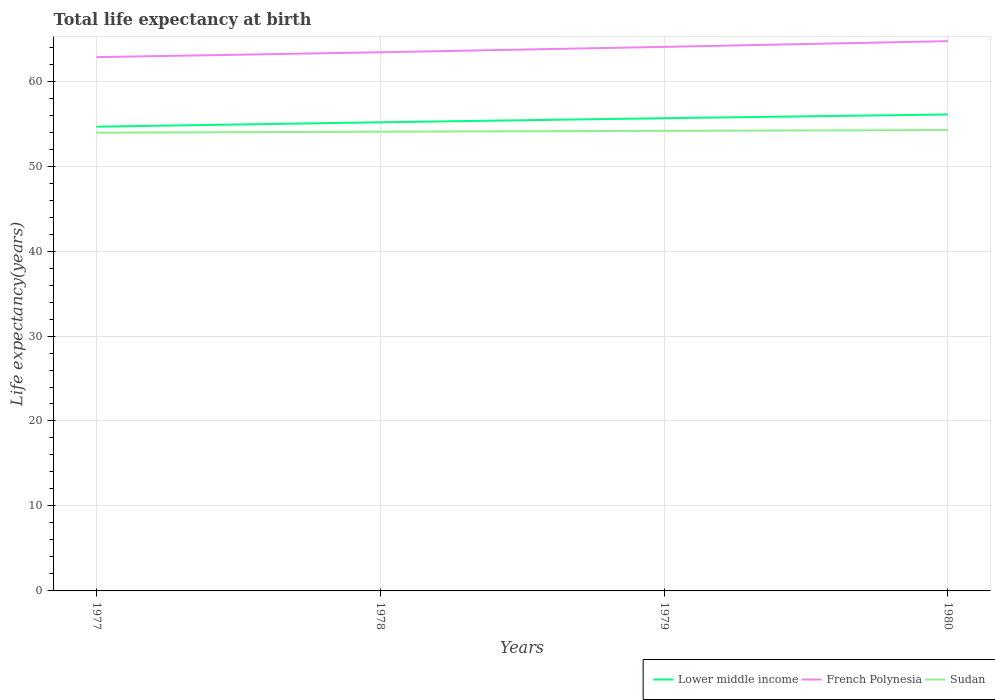Is the number of lines equal to the number of legend labels?
Your answer should be compact. Yes. Across all years, what is the maximum life expectancy at birth in in French Polynesia?
Your answer should be very brief. 62.82. In which year was the life expectancy at birth in in Lower middle income maximum?
Offer a very short reply. 1977. What is the total life expectancy at birth in in Sudan in the graph?
Provide a short and direct response. -0.12. What is the difference between the highest and the second highest life expectancy at birth in in Lower middle income?
Ensure brevity in your answer.  1.44. Is the life expectancy at birth in in Lower middle income strictly greater than the life expectancy at birth in in Sudan over the years?
Provide a succinct answer. No. How many lines are there?
Give a very brief answer. 3. Are the values on the major ticks of Y-axis written in scientific E-notation?
Your answer should be compact. No. How many legend labels are there?
Your answer should be compact. 3. What is the title of the graph?
Offer a terse response. Total life expectancy at birth. Does "Brunei Darussalam" appear as one of the legend labels in the graph?
Provide a succinct answer. No. What is the label or title of the Y-axis?
Give a very brief answer. Life expectancy(years). What is the Life expectancy(years) of Lower middle income in 1977?
Your answer should be compact. 54.64. What is the Life expectancy(years) in French Polynesia in 1977?
Ensure brevity in your answer.  62.82. What is the Life expectancy(years) of Sudan in 1977?
Provide a short and direct response. 53.93. What is the Life expectancy(years) of Lower middle income in 1978?
Provide a short and direct response. 55.16. What is the Life expectancy(years) in French Polynesia in 1978?
Offer a terse response. 63.4. What is the Life expectancy(years) in Sudan in 1978?
Keep it short and to the point. 54.05. What is the Life expectancy(years) in Lower middle income in 1979?
Offer a terse response. 55.64. What is the Life expectancy(years) of French Polynesia in 1979?
Provide a short and direct response. 64.03. What is the Life expectancy(years) of Sudan in 1979?
Ensure brevity in your answer.  54.15. What is the Life expectancy(years) of Lower middle income in 1980?
Your answer should be compact. 56.08. What is the Life expectancy(years) in French Polynesia in 1980?
Your answer should be very brief. 64.71. What is the Life expectancy(years) in Sudan in 1980?
Provide a succinct answer. 54.24. Across all years, what is the maximum Life expectancy(years) in Lower middle income?
Your response must be concise. 56.08. Across all years, what is the maximum Life expectancy(years) of French Polynesia?
Your response must be concise. 64.71. Across all years, what is the maximum Life expectancy(years) of Sudan?
Make the answer very short. 54.24. Across all years, what is the minimum Life expectancy(years) in Lower middle income?
Provide a short and direct response. 54.64. Across all years, what is the minimum Life expectancy(years) in French Polynesia?
Offer a very short reply. 62.82. Across all years, what is the minimum Life expectancy(years) of Sudan?
Your response must be concise. 53.93. What is the total Life expectancy(years) of Lower middle income in the graph?
Ensure brevity in your answer.  221.51. What is the total Life expectancy(years) in French Polynesia in the graph?
Provide a succinct answer. 254.96. What is the total Life expectancy(years) in Sudan in the graph?
Keep it short and to the point. 216.37. What is the difference between the Life expectancy(years) in Lower middle income in 1977 and that in 1978?
Ensure brevity in your answer.  -0.52. What is the difference between the Life expectancy(years) in French Polynesia in 1977 and that in 1978?
Keep it short and to the point. -0.57. What is the difference between the Life expectancy(years) in Sudan in 1977 and that in 1978?
Ensure brevity in your answer.  -0.12. What is the difference between the Life expectancy(years) of Lower middle income in 1977 and that in 1979?
Provide a short and direct response. -1. What is the difference between the Life expectancy(years) of French Polynesia in 1977 and that in 1979?
Keep it short and to the point. -1.21. What is the difference between the Life expectancy(years) in Sudan in 1977 and that in 1979?
Offer a terse response. -0.22. What is the difference between the Life expectancy(years) of Lower middle income in 1977 and that in 1980?
Give a very brief answer. -1.44. What is the difference between the Life expectancy(years) in French Polynesia in 1977 and that in 1980?
Keep it short and to the point. -1.88. What is the difference between the Life expectancy(years) of Sudan in 1977 and that in 1980?
Offer a very short reply. -0.31. What is the difference between the Life expectancy(years) of Lower middle income in 1978 and that in 1979?
Your response must be concise. -0.48. What is the difference between the Life expectancy(years) of French Polynesia in 1978 and that in 1979?
Your response must be concise. -0.64. What is the difference between the Life expectancy(years) in Lower middle income in 1978 and that in 1980?
Keep it short and to the point. -0.92. What is the difference between the Life expectancy(years) in French Polynesia in 1978 and that in 1980?
Offer a very short reply. -1.31. What is the difference between the Life expectancy(years) of Sudan in 1978 and that in 1980?
Ensure brevity in your answer.  -0.19. What is the difference between the Life expectancy(years) of Lower middle income in 1979 and that in 1980?
Give a very brief answer. -0.44. What is the difference between the Life expectancy(years) of French Polynesia in 1979 and that in 1980?
Your answer should be compact. -0.67. What is the difference between the Life expectancy(years) of Sudan in 1979 and that in 1980?
Make the answer very short. -0.09. What is the difference between the Life expectancy(years) in Lower middle income in 1977 and the Life expectancy(years) in French Polynesia in 1978?
Your answer should be very brief. -8.76. What is the difference between the Life expectancy(years) in Lower middle income in 1977 and the Life expectancy(years) in Sudan in 1978?
Give a very brief answer. 0.59. What is the difference between the Life expectancy(years) in French Polynesia in 1977 and the Life expectancy(years) in Sudan in 1978?
Your answer should be very brief. 8.78. What is the difference between the Life expectancy(years) of Lower middle income in 1977 and the Life expectancy(years) of French Polynesia in 1979?
Your answer should be compact. -9.39. What is the difference between the Life expectancy(years) of Lower middle income in 1977 and the Life expectancy(years) of Sudan in 1979?
Offer a very short reply. 0.49. What is the difference between the Life expectancy(years) of French Polynesia in 1977 and the Life expectancy(years) of Sudan in 1979?
Your answer should be compact. 8.68. What is the difference between the Life expectancy(years) in Lower middle income in 1977 and the Life expectancy(years) in French Polynesia in 1980?
Make the answer very short. -10.07. What is the difference between the Life expectancy(years) in Lower middle income in 1977 and the Life expectancy(years) in Sudan in 1980?
Provide a succinct answer. 0.4. What is the difference between the Life expectancy(years) of French Polynesia in 1977 and the Life expectancy(years) of Sudan in 1980?
Your response must be concise. 8.58. What is the difference between the Life expectancy(years) in Lower middle income in 1978 and the Life expectancy(years) in French Polynesia in 1979?
Give a very brief answer. -8.88. What is the difference between the Life expectancy(years) in Lower middle income in 1978 and the Life expectancy(years) in Sudan in 1979?
Your response must be concise. 1.01. What is the difference between the Life expectancy(years) of French Polynesia in 1978 and the Life expectancy(years) of Sudan in 1979?
Your response must be concise. 9.25. What is the difference between the Life expectancy(years) in Lower middle income in 1978 and the Life expectancy(years) in French Polynesia in 1980?
Your answer should be very brief. -9.55. What is the difference between the Life expectancy(years) of Lower middle income in 1978 and the Life expectancy(years) of Sudan in 1980?
Keep it short and to the point. 0.92. What is the difference between the Life expectancy(years) in French Polynesia in 1978 and the Life expectancy(years) in Sudan in 1980?
Offer a very short reply. 9.15. What is the difference between the Life expectancy(years) in Lower middle income in 1979 and the Life expectancy(years) in French Polynesia in 1980?
Your response must be concise. -9.07. What is the difference between the Life expectancy(years) in Lower middle income in 1979 and the Life expectancy(years) in Sudan in 1980?
Your response must be concise. 1.4. What is the difference between the Life expectancy(years) of French Polynesia in 1979 and the Life expectancy(years) of Sudan in 1980?
Provide a short and direct response. 9.79. What is the average Life expectancy(years) in Lower middle income per year?
Give a very brief answer. 55.38. What is the average Life expectancy(years) of French Polynesia per year?
Offer a terse response. 63.74. What is the average Life expectancy(years) in Sudan per year?
Make the answer very short. 54.09. In the year 1977, what is the difference between the Life expectancy(years) of Lower middle income and Life expectancy(years) of French Polynesia?
Make the answer very short. -8.19. In the year 1977, what is the difference between the Life expectancy(years) of Lower middle income and Life expectancy(years) of Sudan?
Offer a very short reply. 0.71. In the year 1977, what is the difference between the Life expectancy(years) of French Polynesia and Life expectancy(years) of Sudan?
Offer a terse response. 8.89. In the year 1978, what is the difference between the Life expectancy(years) of Lower middle income and Life expectancy(years) of French Polynesia?
Make the answer very short. -8.24. In the year 1978, what is the difference between the Life expectancy(years) in Lower middle income and Life expectancy(years) in Sudan?
Provide a succinct answer. 1.11. In the year 1978, what is the difference between the Life expectancy(years) in French Polynesia and Life expectancy(years) in Sudan?
Ensure brevity in your answer.  9.35. In the year 1979, what is the difference between the Life expectancy(years) of Lower middle income and Life expectancy(years) of French Polynesia?
Keep it short and to the point. -8.39. In the year 1979, what is the difference between the Life expectancy(years) of Lower middle income and Life expectancy(years) of Sudan?
Make the answer very short. 1.49. In the year 1979, what is the difference between the Life expectancy(years) in French Polynesia and Life expectancy(years) in Sudan?
Your answer should be compact. 9.88. In the year 1980, what is the difference between the Life expectancy(years) of Lower middle income and Life expectancy(years) of French Polynesia?
Your response must be concise. -8.63. In the year 1980, what is the difference between the Life expectancy(years) in Lower middle income and Life expectancy(years) in Sudan?
Your answer should be very brief. 1.84. In the year 1980, what is the difference between the Life expectancy(years) of French Polynesia and Life expectancy(years) of Sudan?
Give a very brief answer. 10.46. What is the ratio of the Life expectancy(years) in Lower middle income in 1977 to that in 1978?
Your response must be concise. 0.99. What is the ratio of the Life expectancy(years) of French Polynesia in 1977 to that in 1978?
Provide a short and direct response. 0.99. What is the ratio of the Life expectancy(years) in Sudan in 1977 to that in 1978?
Ensure brevity in your answer.  1. What is the ratio of the Life expectancy(years) in Lower middle income in 1977 to that in 1979?
Make the answer very short. 0.98. What is the ratio of the Life expectancy(years) of French Polynesia in 1977 to that in 1979?
Provide a succinct answer. 0.98. What is the ratio of the Life expectancy(years) of Lower middle income in 1977 to that in 1980?
Your answer should be compact. 0.97. What is the ratio of the Life expectancy(years) in French Polynesia in 1977 to that in 1980?
Offer a terse response. 0.97. What is the ratio of the Life expectancy(years) of Sudan in 1977 to that in 1980?
Your answer should be very brief. 0.99. What is the ratio of the Life expectancy(years) of Sudan in 1978 to that in 1979?
Offer a terse response. 1. What is the ratio of the Life expectancy(years) in Lower middle income in 1978 to that in 1980?
Provide a succinct answer. 0.98. What is the ratio of the Life expectancy(years) of French Polynesia in 1978 to that in 1980?
Offer a terse response. 0.98. What is the ratio of the Life expectancy(years) in Lower middle income in 1979 to that in 1980?
Your answer should be compact. 0.99. What is the ratio of the Life expectancy(years) in French Polynesia in 1979 to that in 1980?
Provide a succinct answer. 0.99. What is the ratio of the Life expectancy(years) of Sudan in 1979 to that in 1980?
Offer a very short reply. 1. What is the difference between the highest and the second highest Life expectancy(years) of Lower middle income?
Offer a terse response. 0.44. What is the difference between the highest and the second highest Life expectancy(years) in French Polynesia?
Your answer should be compact. 0.67. What is the difference between the highest and the second highest Life expectancy(years) of Sudan?
Your response must be concise. 0.09. What is the difference between the highest and the lowest Life expectancy(years) of Lower middle income?
Ensure brevity in your answer.  1.44. What is the difference between the highest and the lowest Life expectancy(years) in French Polynesia?
Offer a very short reply. 1.88. What is the difference between the highest and the lowest Life expectancy(years) in Sudan?
Your response must be concise. 0.31. 